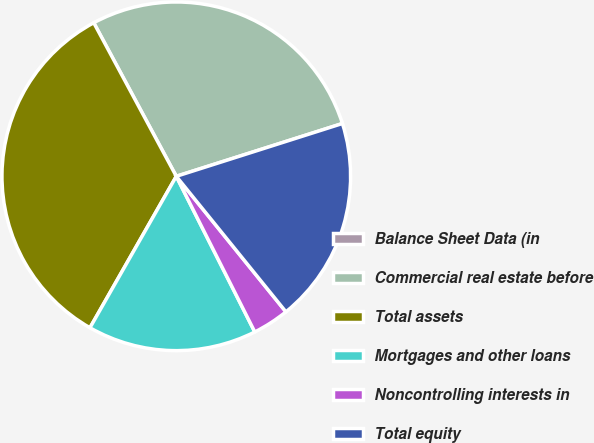Convert chart. <chart><loc_0><loc_0><loc_500><loc_500><pie_chart><fcel>Balance Sheet Data (in<fcel>Commercial real estate before<fcel>Total assets<fcel>Mortgages and other loans<fcel>Noncontrolling interests in<fcel>Total equity<nl><fcel>0.0%<fcel>27.95%<fcel>33.9%<fcel>15.68%<fcel>3.39%<fcel>19.07%<nl></chart> 